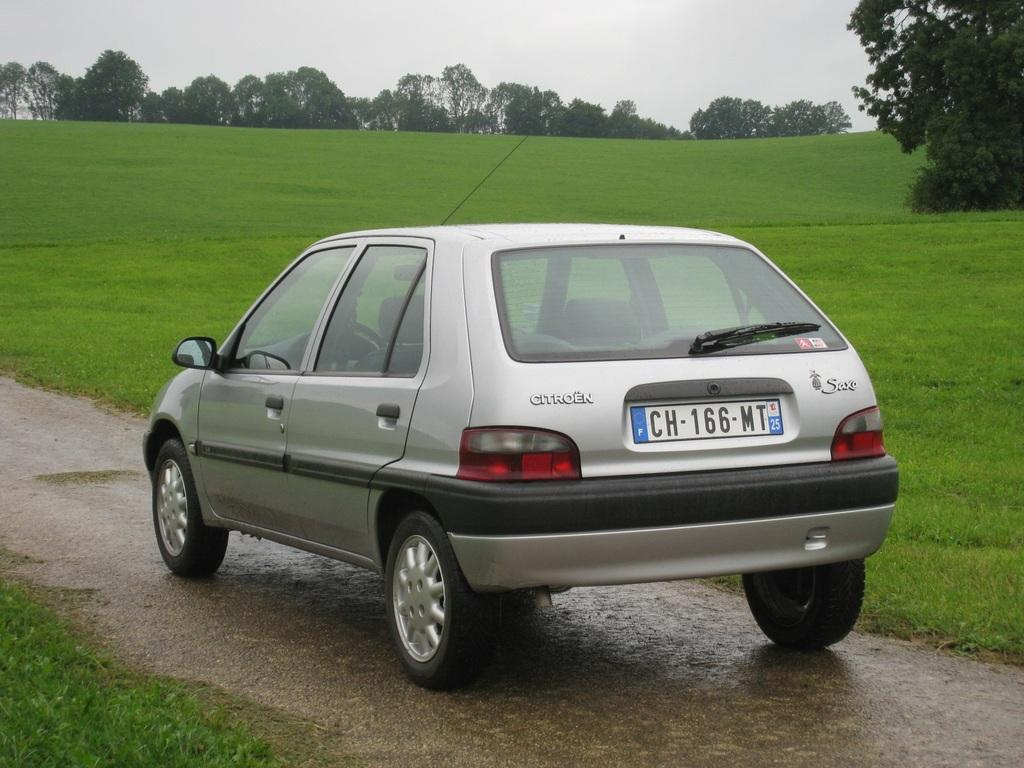What is the main subject of the image? There is a car in the image. Can you describe the color of the car? The car is silver and black in color. Where is the car located in the image? The car is on the road. What can be seen on both sides of the road? There is grass on both sides of the road. What is visible in the background of the image? There are trees and the sky in the background of the image. What type of bomb can be seen exploding near the car in the image? There is no bomb or explosion present in the image; it only features a car on the road with grass on both sides and trees and the sky in the background. 